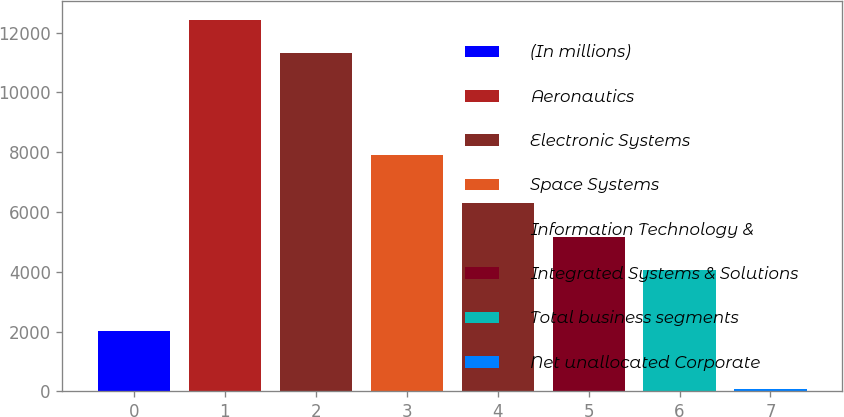<chart> <loc_0><loc_0><loc_500><loc_500><bar_chart><fcel>(In millions)<fcel>Aeronautics<fcel>Electronic Systems<fcel>Space Systems<fcel>Information Technology &<fcel>Integrated Systems & Solutions<fcel>Total business segments<fcel>Net unallocated Corporate<nl><fcel>2006<fcel>12434.6<fcel>11304<fcel>7923<fcel>6309.2<fcel>5178.6<fcel>4048<fcel>95<nl></chart> 